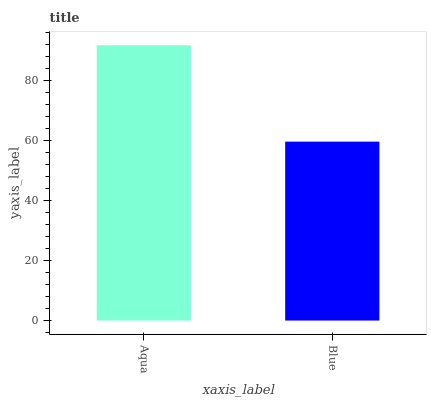Is Blue the minimum?
Answer yes or no. Yes. Is Aqua the maximum?
Answer yes or no. Yes. Is Blue the maximum?
Answer yes or no. No. Is Aqua greater than Blue?
Answer yes or no. Yes. Is Blue less than Aqua?
Answer yes or no. Yes. Is Blue greater than Aqua?
Answer yes or no. No. Is Aqua less than Blue?
Answer yes or no. No. Is Aqua the high median?
Answer yes or no. Yes. Is Blue the low median?
Answer yes or no. Yes. Is Blue the high median?
Answer yes or no. No. Is Aqua the low median?
Answer yes or no. No. 